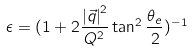<formula> <loc_0><loc_0><loc_500><loc_500>\epsilon = ( 1 + 2 \frac { { | \vec { q } | } ^ { 2 } } { Q ^ { 2 } } \tan ^ { 2 } \frac { \theta _ { e } } { 2 } ) ^ { - 1 }</formula> 